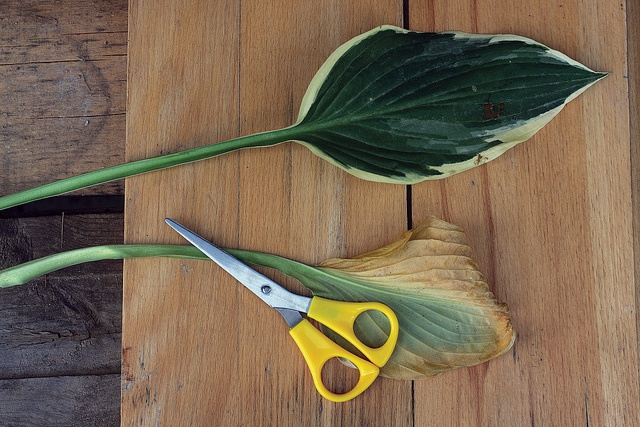Describe the objects in this image and their specific colors. I can see dining table in gray, brown, tan, and black tones and scissors in brown, gold, and gray tones in this image. 